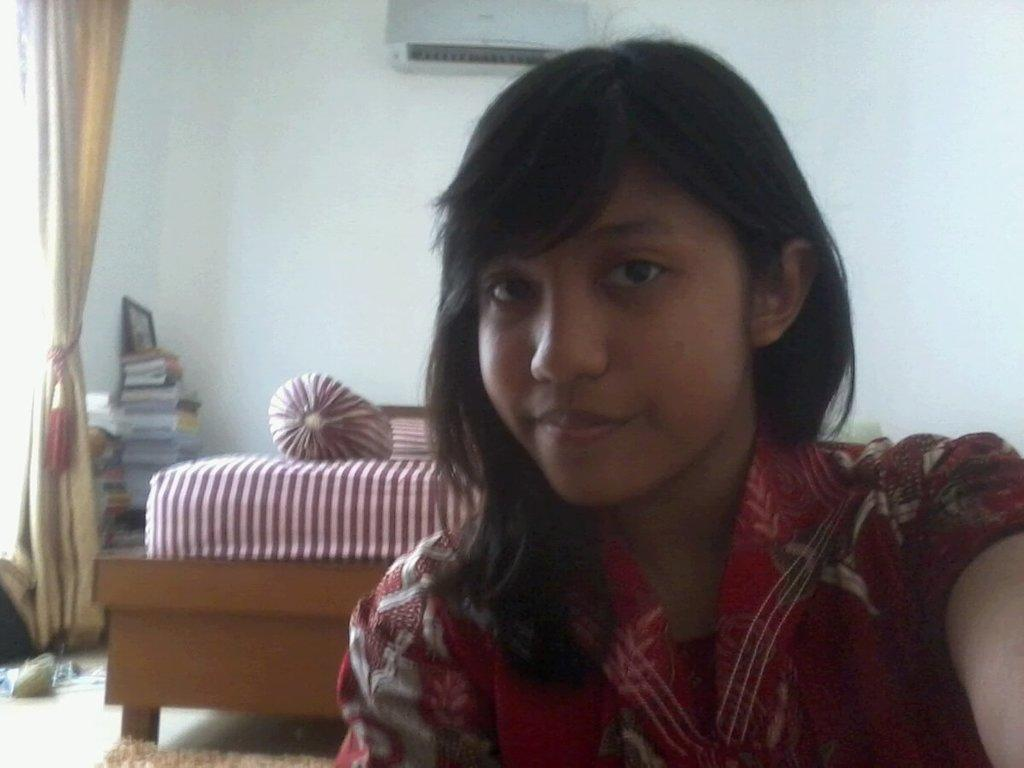Who is present in the image? There is a woman in the image. Where is the woman located? The woman is in a room. What furniture can be seen in the room? There is a bed in the room. What items are present in the room for reading or learning? There are books in the room. What type of window treatment is present in the room? There is a curtain in the room. What device is present in the room for cooling the air? There is an air conditioner in the room. Can you tell me how many firemen are visible in the image? There are no firemen present in the image. What type of root can be seen growing in the image? There is no root visible in the image. 